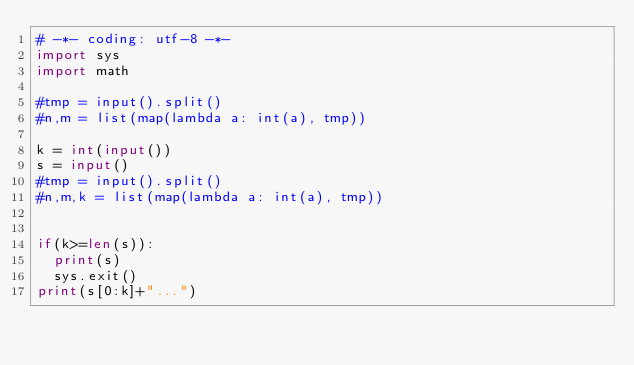Convert code to text. <code><loc_0><loc_0><loc_500><loc_500><_Python_># -*- coding: utf-8 -*-
import sys
import math

#tmp = input().split()
#n,m = list(map(lambda a: int(a), tmp))

k = int(input())
s = input()
#tmp = input().split()
#n,m,k = list(map(lambda a: int(a), tmp))


if(k>=len(s)):
	print(s)
	sys.exit()
print(s[0:k]+"...")



</code> 